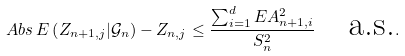<formula> <loc_0><loc_0><loc_500><loc_500>\ A b s { \, E \left ( Z _ { n + 1 , j } | \mathcal { G } _ { n } \right ) - Z _ { n , j } } \leq \frac { \sum _ { i = 1 } ^ { d } E A _ { n + 1 , i } ^ { 2 } } { S _ { n } ^ { 2 } } \quad \text {a.s.} .</formula> 